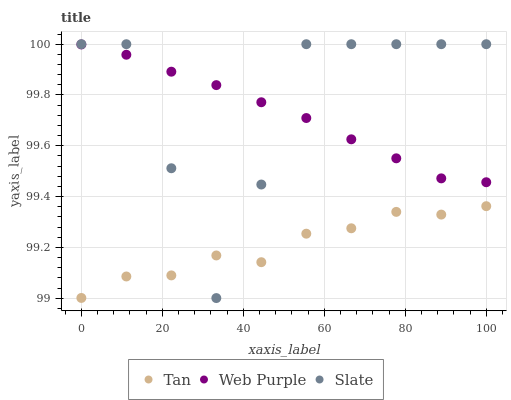Does Tan have the minimum area under the curve?
Answer yes or no. Yes. Does Slate have the maximum area under the curve?
Answer yes or no. Yes. Does Web Purple have the minimum area under the curve?
Answer yes or no. No. Does Web Purple have the maximum area under the curve?
Answer yes or no. No. Is Web Purple the smoothest?
Answer yes or no. Yes. Is Slate the roughest?
Answer yes or no. Yes. Is Slate the smoothest?
Answer yes or no. No. Is Web Purple the roughest?
Answer yes or no. No. Does Slate have the lowest value?
Answer yes or no. Yes. Does Web Purple have the lowest value?
Answer yes or no. No. Does Slate have the highest value?
Answer yes or no. Yes. Does Web Purple have the highest value?
Answer yes or no. No. Is Tan less than Web Purple?
Answer yes or no. Yes. Is Web Purple greater than Tan?
Answer yes or no. Yes. Does Tan intersect Slate?
Answer yes or no. Yes. Is Tan less than Slate?
Answer yes or no. No. Is Tan greater than Slate?
Answer yes or no. No. Does Tan intersect Web Purple?
Answer yes or no. No. 